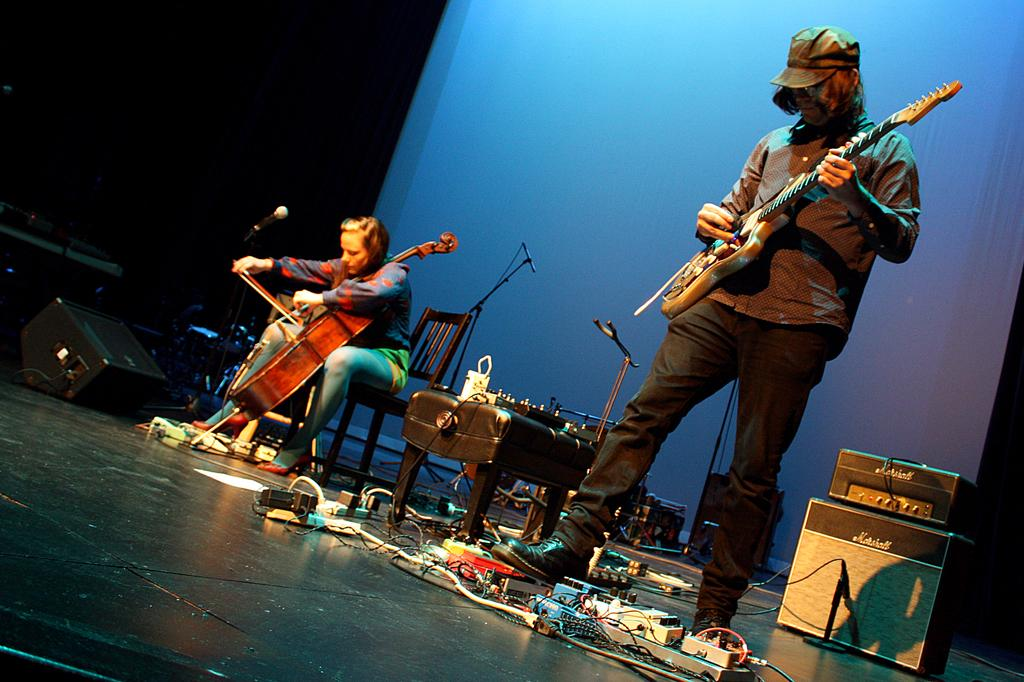What is the man in the image doing? The man is standing and holding a guitar. What is the woman in the image doing? The woman is sitting and playing a piano. What objects are present that might be used for amplifying sound? There are microphones present in the image. What type of roof can be seen on the building in the image? There is no building or roof present in the image. How does the woman twist the piano keys in the image? The woman is not twisting the piano keys in the image; she is playing the piano in a typical manner. 